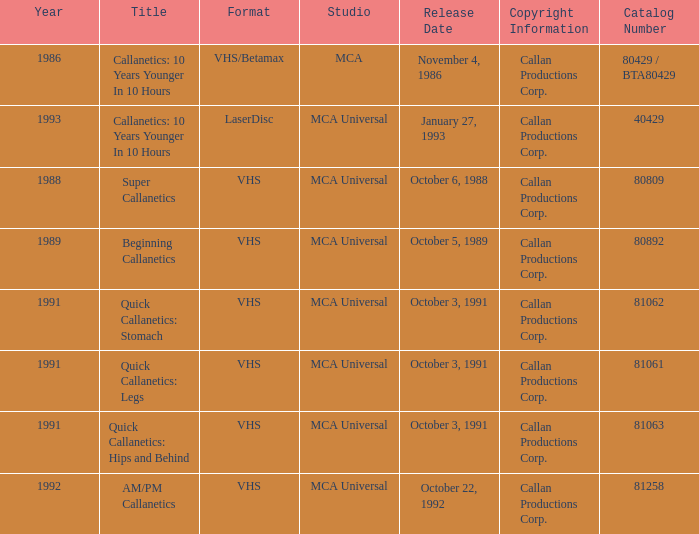Can you name the style for quick callanetics exercises aimed at hips and buttocks? VHS. 